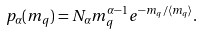Convert formula to latex. <formula><loc_0><loc_0><loc_500><loc_500>p _ { \alpha } ( m _ { q } ) = N _ { \alpha } m _ { q } ^ { \alpha - 1 } e ^ { - m _ { q } / \langle m _ { q } \rangle } .</formula> 